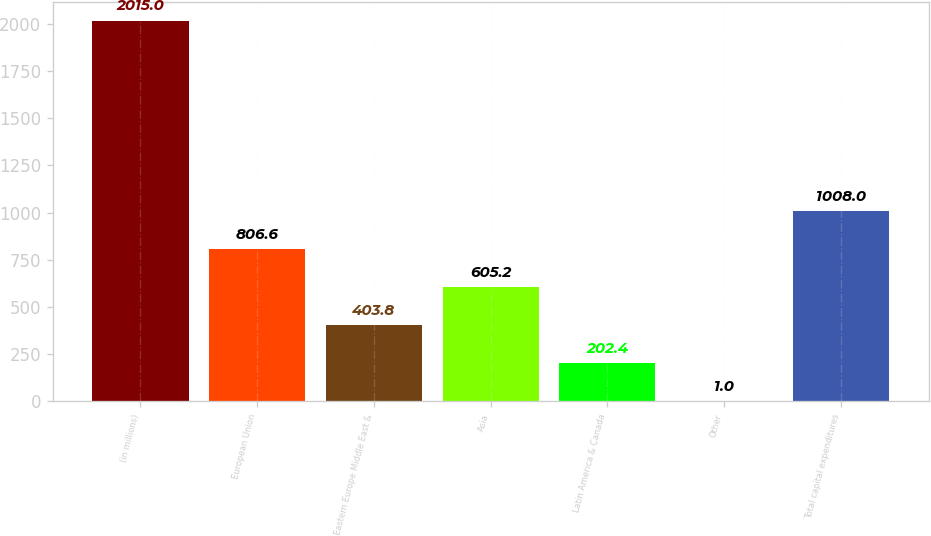Convert chart to OTSL. <chart><loc_0><loc_0><loc_500><loc_500><bar_chart><fcel>(in millions)<fcel>European Union<fcel>Eastern Europe Middle East &<fcel>Asia<fcel>Latin America & Canada<fcel>Other<fcel>Total capital expenditures<nl><fcel>2015<fcel>806.6<fcel>403.8<fcel>605.2<fcel>202.4<fcel>1<fcel>1008<nl></chart> 